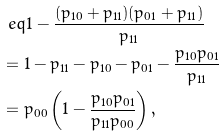Convert formula to latex. <formula><loc_0><loc_0><loc_500><loc_500>& \ e q 1 - \frac { ( p _ { 1 0 } + p _ { 1 1 } ) ( p _ { 0 1 } + p _ { 1 1 } ) } { p _ { 1 1 } } \\ & = 1 - p _ { 1 1 } - p _ { 1 0 } - p _ { 0 1 } - \frac { p _ { 1 0 } p _ { 0 1 } } { p _ { 1 1 } } \\ & = p _ { 0 0 } \left ( 1 - \frac { p _ { 1 0 } p _ { 0 1 } } { p _ { 1 1 } p _ { 0 0 } } \right ) ,</formula> 